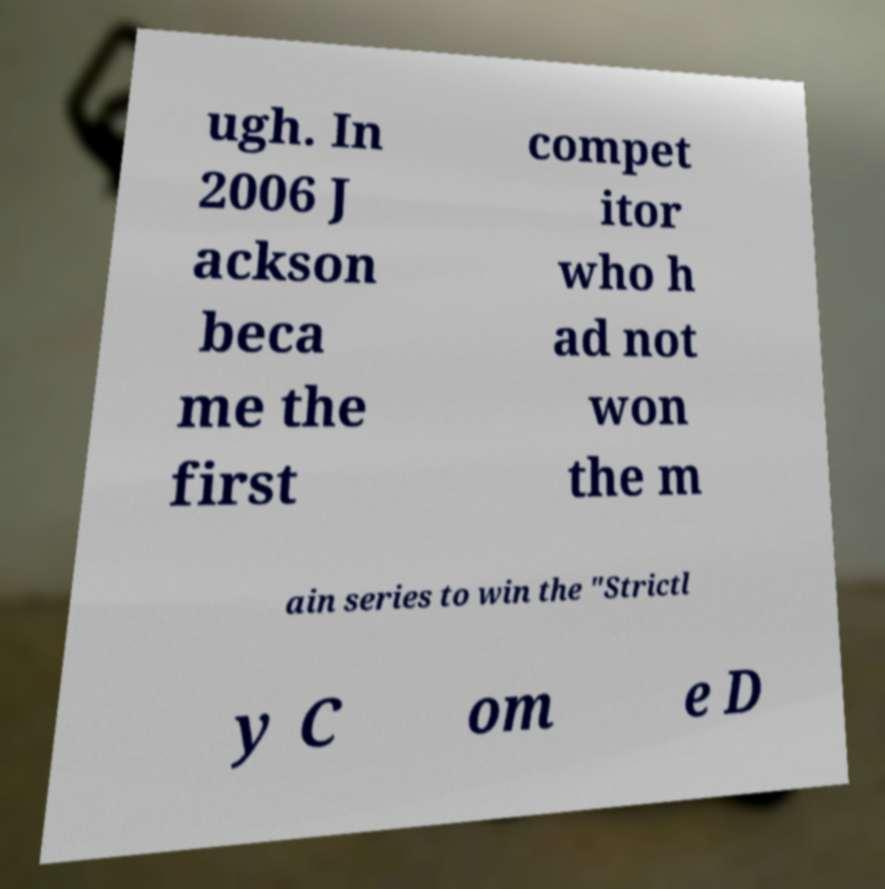There's text embedded in this image that I need extracted. Can you transcribe it verbatim? ugh. In 2006 J ackson beca me the first compet itor who h ad not won the m ain series to win the "Strictl y C om e D 